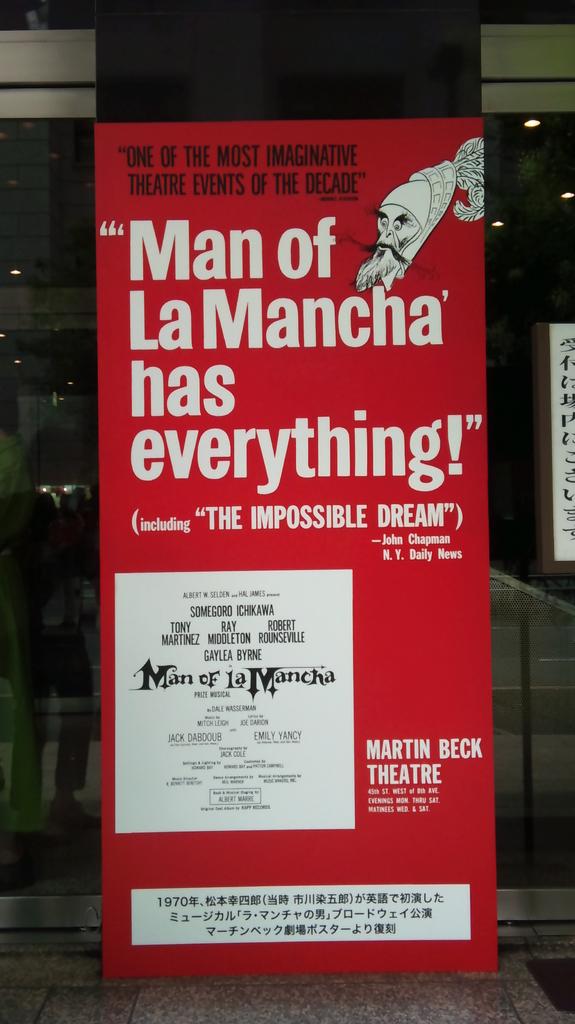What does the man of lamancha have?
Provide a succinct answer. Everything. What is the theater name?
Your response must be concise. Martin beck theatre. 